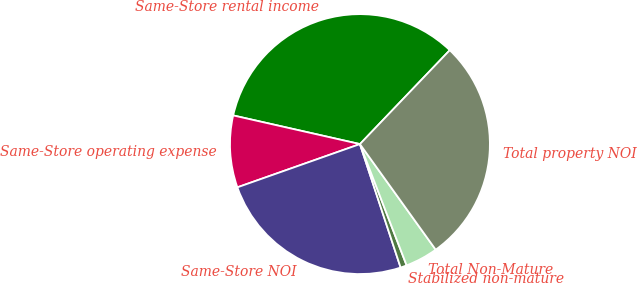Convert chart. <chart><loc_0><loc_0><loc_500><loc_500><pie_chart><fcel>Same-Store rental income<fcel>Same-Store operating expense<fcel>Same-Store NOI<fcel>Stabilized non-mature<fcel>Total Non-Mature<fcel>Total property NOI<nl><fcel>33.61%<fcel>8.94%<fcel>24.67%<fcel>0.78%<fcel>4.06%<fcel>27.95%<nl></chart> 